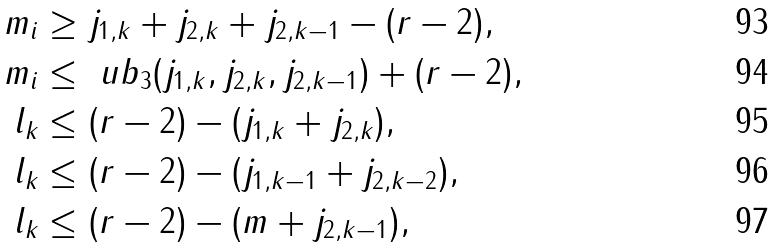Convert formula to latex. <formula><loc_0><loc_0><loc_500><loc_500>m _ { i } & \geq j _ { 1 , k } + j _ { 2 , k } + j _ { 2 , k - 1 } - ( r - 2 ) , \\ m _ { i } & \leq \ u b _ { 3 } ( j _ { 1 , k } , j _ { 2 , k } , j _ { 2 , k - 1 } ) + ( r - 2 ) , \\ l _ { k } & \leq ( r - 2 ) - ( j _ { 1 , k } + j _ { 2 , k } ) , \\ l _ { k } & \leq ( r - 2 ) - ( j _ { 1 , k - 1 } + j _ { 2 , k - 2 } ) , \\ l _ { k } & \leq ( r - 2 ) - ( m + j _ { 2 , k - 1 } ) ,</formula> 